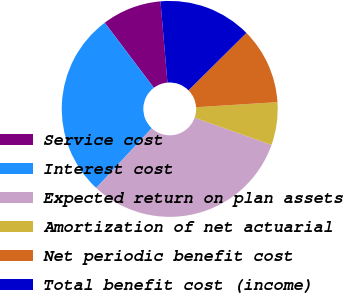Convert chart. <chart><loc_0><loc_0><loc_500><loc_500><pie_chart><fcel>Service cost<fcel>Interest cost<fcel>Expected return on plan assets<fcel>Amortization of net actuarial<fcel>Net periodic benefit cost<fcel>Total benefit cost (income)<nl><fcel>8.92%<fcel>27.8%<fcel>31.51%<fcel>6.41%<fcel>11.43%<fcel>13.94%<nl></chart> 